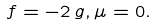<formula> <loc_0><loc_0><loc_500><loc_500>f = - 2 \, g , \mu = 0 .</formula> 